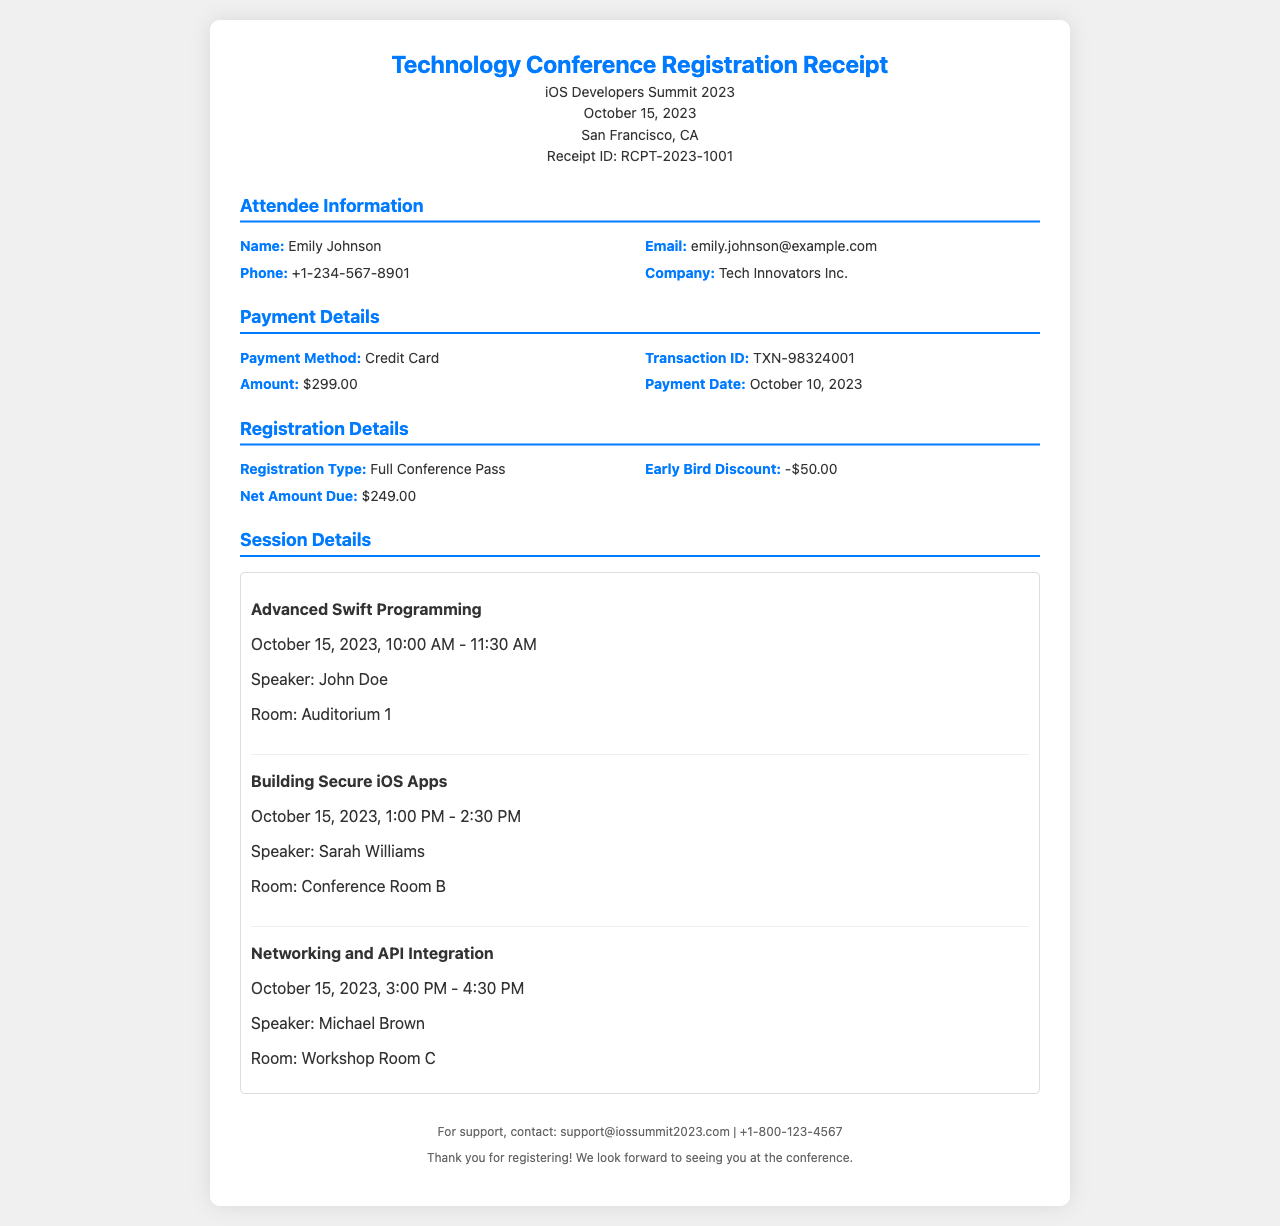What is the receipt ID? The receipt ID is a unique identifier for this registration, which can be found in the header section of the document.
Answer: RCPT-2023-1001 Who is the attendee? This refers to the person registering for the conference, found in the Attendee Information section.
Answer: Emily Johnson What is the payment amount? The payment amount is specified in the Payment Details section and indicates the cost of registration.
Answer: $299.00 What type of registration was made? This indicates the kind of pass purchased for the conference, found in the Registration Details section.
Answer: Full Conference Pass What is the early bird discount? This reflects a promotional reduction in the registration fee, located in the Registration Details section.
Answer: -$50.00 Which session begins at 1:00 PM? This requires identification of the session time from the Session Details section and the associated session title.
Answer: Building Secure iOS Apps How many sessions are listed? This is determined by counting the individual session items described in the Session Details section of the document.
Answer: 3 What is the contact email for support? This information is typically found in the footer section, providing assistance contact details for attendees.
Answer: support@iossummit2023.com What date is the conference held? The date of the conference is presented in the header section of the receipt.
Answer: October 15, 2023 